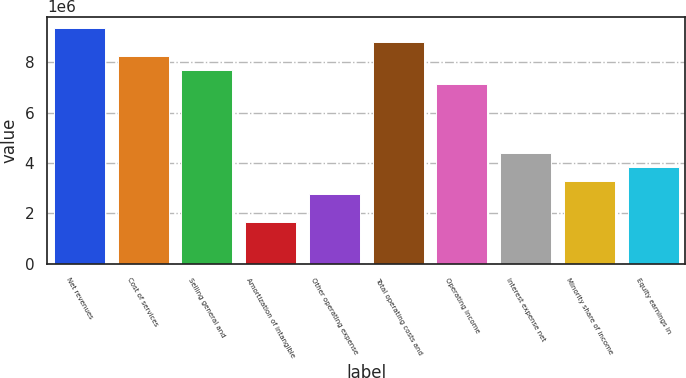<chart> <loc_0><loc_0><loc_500><loc_500><bar_chart><fcel>Net revenues<fcel>Cost of services<fcel>Selling general and<fcel>Amortization of intangible<fcel>Other operating expense<fcel>Total operating costs and<fcel>Operating income<fcel>Interest expense net<fcel>Minority share of income<fcel>Equity earnings in<nl><fcel>9.35631e+06<fcel>8.25557e+06<fcel>7.7052e+06<fcel>1.65111e+06<fcel>2.75186e+06<fcel>8.80594e+06<fcel>7.15482e+06<fcel>4.40297e+06<fcel>3.30223e+06<fcel>3.8526e+06<nl></chart> 